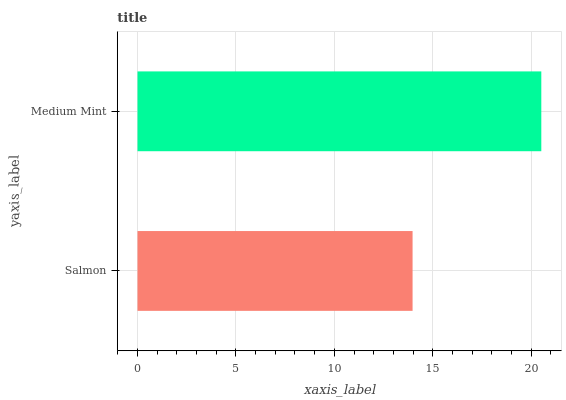Is Salmon the minimum?
Answer yes or no. Yes. Is Medium Mint the maximum?
Answer yes or no. Yes. Is Medium Mint the minimum?
Answer yes or no. No. Is Medium Mint greater than Salmon?
Answer yes or no. Yes. Is Salmon less than Medium Mint?
Answer yes or no. Yes. Is Salmon greater than Medium Mint?
Answer yes or no. No. Is Medium Mint less than Salmon?
Answer yes or no. No. Is Medium Mint the high median?
Answer yes or no. Yes. Is Salmon the low median?
Answer yes or no. Yes. Is Salmon the high median?
Answer yes or no. No. Is Medium Mint the low median?
Answer yes or no. No. 